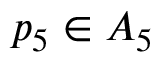<formula> <loc_0><loc_0><loc_500><loc_500>p _ { 5 } \in A _ { 5 }</formula> 